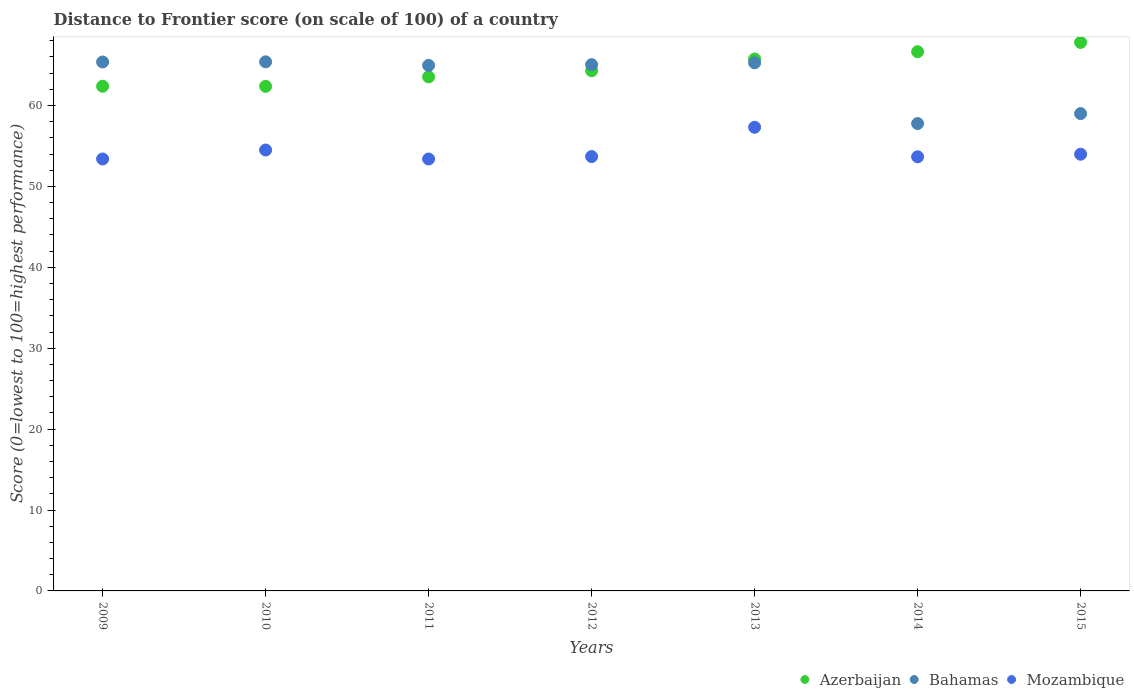Is the number of dotlines equal to the number of legend labels?
Your answer should be compact. Yes. What is the distance to frontier score of in Mozambique in 2010?
Make the answer very short. 54.5. Across all years, what is the maximum distance to frontier score of in Mozambique?
Your answer should be compact. 57.31. Across all years, what is the minimum distance to frontier score of in Azerbaijan?
Keep it short and to the point. 62.37. What is the total distance to frontier score of in Azerbaijan in the graph?
Provide a succinct answer. 452.78. What is the difference between the distance to frontier score of in Bahamas in 2012 and that in 2013?
Offer a very short reply. -0.23. What is the difference between the distance to frontier score of in Azerbaijan in 2014 and the distance to frontier score of in Bahamas in 2009?
Offer a terse response. 1.27. What is the average distance to frontier score of in Azerbaijan per year?
Offer a very short reply. 64.68. In the year 2009, what is the difference between the distance to frontier score of in Bahamas and distance to frontier score of in Azerbaijan?
Offer a terse response. 3. What is the ratio of the distance to frontier score of in Mozambique in 2012 to that in 2014?
Ensure brevity in your answer.  1. What is the difference between the highest and the second highest distance to frontier score of in Mozambique?
Your answer should be compact. 2.81. What is the difference between the highest and the lowest distance to frontier score of in Mozambique?
Ensure brevity in your answer.  3.92. Is the sum of the distance to frontier score of in Bahamas in 2013 and 2014 greater than the maximum distance to frontier score of in Mozambique across all years?
Provide a short and direct response. Yes. Is it the case that in every year, the sum of the distance to frontier score of in Bahamas and distance to frontier score of in Azerbaijan  is greater than the distance to frontier score of in Mozambique?
Ensure brevity in your answer.  Yes. Does the distance to frontier score of in Bahamas monotonically increase over the years?
Ensure brevity in your answer.  No. What is the difference between two consecutive major ticks on the Y-axis?
Provide a short and direct response. 10. Are the values on the major ticks of Y-axis written in scientific E-notation?
Keep it short and to the point. No. Where does the legend appear in the graph?
Make the answer very short. Bottom right. How many legend labels are there?
Provide a short and direct response. 3. What is the title of the graph?
Offer a very short reply. Distance to Frontier score (on scale of 100) of a country. Does "Latin America(developing only)" appear as one of the legend labels in the graph?
Your answer should be very brief. No. What is the label or title of the Y-axis?
Your answer should be very brief. Score (0=lowest to 100=highest performance). What is the Score (0=lowest to 100=highest performance) of Azerbaijan in 2009?
Your answer should be compact. 62.38. What is the Score (0=lowest to 100=highest performance) of Bahamas in 2009?
Offer a terse response. 65.38. What is the Score (0=lowest to 100=highest performance) of Mozambique in 2009?
Offer a very short reply. 53.39. What is the Score (0=lowest to 100=highest performance) of Azerbaijan in 2010?
Provide a succinct answer. 62.37. What is the Score (0=lowest to 100=highest performance) in Bahamas in 2010?
Provide a short and direct response. 65.4. What is the Score (0=lowest to 100=highest performance) of Mozambique in 2010?
Provide a succinct answer. 54.5. What is the Score (0=lowest to 100=highest performance) in Azerbaijan in 2011?
Give a very brief answer. 63.54. What is the Score (0=lowest to 100=highest performance) in Bahamas in 2011?
Give a very brief answer. 64.96. What is the Score (0=lowest to 100=highest performance) in Mozambique in 2011?
Offer a very short reply. 53.39. What is the Score (0=lowest to 100=highest performance) in Azerbaijan in 2012?
Make the answer very short. 64.3. What is the Score (0=lowest to 100=highest performance) in Bahamas in 2012?
Your answer should be compact. 65.05. What is the Score (0=lowest to 100=highest performance) of Mozambique in 2012?
Your answer should be compact. 53.69. What is the Score (0=lowest to 100=highest performance) of Azerbaijan in 2013?
Offer a terse response. 65.74. What is the Score (0=lowest to 100=highest performance) in Bahamas in 2013?
Your answer should be compact. 65.28. What is the Score (0=lowest to 100=highest performance) in Mozambique in 2013?
Offer a terse response. 57.31. What is the Score (0=lowest to 100=highest performance) of Azerbaijan in 2014?
Your response must be concise. 66.65. What is the Score (0=lowest to 100=highest performance) of Bahamas in 2014?
Provide a succinct answer. 57.77. What is the Score (0=lowest to 100=highest performance) of Mozambique in 2014?
Offer a very short reply. 53.66. What is the Score (0=lowest to 100=highest performance) of Azerbaijan in 2015?
Provide a short and direct response. 67.8. What is the Score (0=lowest to 100=highest performance) in Bahamas in 2015?
Keep it short and to the point. 59. What is the Score (0=lowest to 100=highest performance) in Mozambique in 2015?
Provide a succinct answer. 53.98. Across all years, what is the maximum Score (0=lowest to 100=highest performance) of Azerbaijan?
Keep it short and to the point. 67.8. Across all years, what is the maximum Score (0=lowest to 100=highest performance) of Bahamas?
Ensure brevity in your answer.  65.4. Across all years, what is the maximum Score (0=lowest to 100=highest performance) in Mozambique?
Offer a very short reply. 57.31. Across all years, what is the minimum Score (0=lowest to 100=highest performance) in Azerbaijan?
Give a very brief answer. 62.37. Across all years, what is the minimum Score (0=lowest to 100=highest performance) in Bahamas?
Your answer should be very brief. 57.77. Across all years, what is the minimum Score (0=lowest to 100=highest performance) of Mozambique?
Provide a succinct answer. 53.39. What is the total Score (0=lowest to 100=highest performance) of Azerbaijan in the graph?
Provide a succinct answer. 452.78. What is the total Score (0=lowest to 100=highest performance) in Bahamas in the graph?
Offer a very short reply. 442.84. What is the total Score (0=lowest to 100=highest performance) of Mozambique in the graph?
Your response must be concise. 379.92. What is the difference between the Score (0=lowest to 100=highest performance) of Bahamas in 2009 and that in 2010?
Keep it short and to the point. -0.02. What is the difference between the Score (0=lowest to 100=highest performance) in Mozambique in 2009 and that in 2010?
Provide a succinct answer. -1.11. What is the difference between the Score (0=lowest to 100=highest performance) in Azerbaijan in 2009 and that in 2011?
Your answer should be very brief. -1.16. What is the difference between the Score (0=lowest to 100=highest performance) in Bahamas in 2009 and that in 2011?
Provide a short and direct response. 0.42. What is the difference between the Score (0=lowest to 100=highest performance) of Azerbaijan in 2009 and that in 2012?
Offer a terse response. -1.92. What is the difference between the Score (0=lowest to 100=highest performance) of Bahamas in 2009 and that in 2012?
Provide a short and direct response. 0.33. What is the difference between the Score (0=lowest to 100=highest performance) in Mozambique in 2009 and that in 2012?
Provide a succinct answer. -0.3. What is the difference between the Score (0=lowest to 100=highest performance) in Azerbaijan in 2009 and that in 2013?
Your answer should be very brief. -3.36. What is the difference between the Score (0=lowest to 100=highest performance) of Mozambique in 2009 and that in 2013?
Give a very brief answer. -3.92. What is the difference between the Score (0=lowest to 100=highest performance) of Azerbaijan in 2009 and that in 2014?
Keep it short and to the point. -4.27. What is the difference between the Score (0=lowest to 100=highest performance) in Bahamas in 2009 and that in 2014?
Your response must be concise. 7.61. What is the difference between the Score (0=lowest to 100=highest performance) in Mozambique in 2009 and that in 2014?
Ensure brevity in your answer.  -0.27. What is the difference between the Score (0=lowest to 100=highest performance) in Azerbaijan in 2009 and that in 2015?
Provide a succinct answer. -5.42. What is the difference between the Score (0=lowest to 100=highest performance) of Bahamas in 2009 and that in 2015?
Keep it short and to the point. 6.38. What is the difference between the Score (0=lowest to 100=highest performance) in Mozambique in 2009 and that in 2015?
Make the answer very short. -0.59. What is the difference between the Score (0=lowest to 100=highest performance) in Azerbaijan in 2010 and that in 2011?
Keep it short and to the point. -1.17. What is the difference between the Score (0=lowest to 100=highest performance) of Bahamas in 2010 and that in 2011?
Give a very brief answer. 0.44. What is the difference between the Score (0=lowest to 100=highest performance) of Mozambique in 2010 and that in 2011?
Make the answer very short. 1.11. What is the difference between the Score (0=lowest to 100=highest performance) of Azerbaijan in 2010 and that in 2012?
Offer a very short reply. -1.93. What is the difference between the Score (0=lowest to 100=highest performance) of Mozambique in 2010 and that in 2012?
Your answer should be compact. 0.81. What is the difference between the Score (0=lowest to 100=highest performance) of Azerbaijan in 2010 and that in 2013?
Keep it short and to the point. -3.37. What is the difference between the Score (0=lowest to 100=highest performance) of Bahamas in 2010 and that in 2013?
Make the answer very short. 0.12. What is the difference between the Score (0=lowest to 100=highest performance) in Mozambique in 2010 and that in 2013?
Offer a terse response. -2.81. What is the difference between the Score (0=lowest to 100=highest performance) in Azerbaijan in 2010 and that in 2014?
Provide a short and direct response. -4.28. What is the difference between the Score (0=lowest to 100=highest performance) of Bahamas in 2010 and that in 2014?
Ensure brevity in your answer.  7.63. What is the difference between the Score (0=lowest to 100=highest performance) in Mozambique in 2010 and that in 2014?
Provide a succinct answer. 0.84. What is the difference between the Score (0=lowest to 100=highest performance) of Azerbaijan in 2010 and that in 2015?
Your answer should be compact. -5.43. What is the difference between the Score (0=lowest to 100=highest performance) of Mozambique in 2010 and that in 2015?
Give a very brief answer. 0.52. What is the difference between the Score (0=lowest to 100=highest performance) in Azerbaijan in 2011 and that in 2012?
Your answer should be very brief. -0.76. What is the difference between the Score (0=lowest to 100=highest performance) in Bahamas in 2011 and that in 2012?
Give a very brief answer. -0.09. What is the difference between the Score (0=lowest to 100=highest performance) in Mozambique in 2011 and that in 2012?
Offer a terse response. -0.3. What is the difference between the Score (0=lowest to 100=highest performance) of Bahamas in 2011 and that in 2013?
Ensure brevity in your answer.  -0.32. What is the difference between the Score (0=lowest to 100=highest performance) in Mozambique in 2011 and that in 2013?
Offer a terse response. -3.92. What is the difference between the Score (0=lowest to 100=highest performance) of Azerbaijan in 2011 and that in 2014?
Offer a very short reply. -3.11. What is the difference between the Score (0=lowest to 100=highest performance) in Bahamas in 2011 and that in 2014?
Provide a short and direct response. 7.19. What is the difference between the Score (0=lowest to 100=highest performance) in Mozambique in 2011 and that in 2014?
Make the answer very short. -0.27. What is the difference between the Score (0=lowest to 100=highest performance) in Azerbaijan in 2011 and that in 2015?
Your response must be concise. -4.26. What is the difference between the Score (0=lowest to 100=highest performance) of Bahamas in 2011 and that in 2015?
Provide a succinct answer. 5.96. What is the difference between the Score (0=lowest to 100=highest performance) in Mozambique in 2011 and that in 2015?
Ensure brevity in your answer.  -0.59. What is the difference between the Score (0=lowest to 100=highest performance) in Azerbaijan in 2012 and that in 2013?
Keep it short and to the point. -1.44. What is the difference between the Score (0=lowest to 100=highest performance) of Bahamas in 2012 and that in 2013?
Keep it short and to the point. -0.23. What is the difference between the Score (0=lowest to 100=highest performance) of Mozambique in 2012 and that in 2013?
Offer a very short reply. -3.62. What is the difference between the Score (0=lowest to 100=highest performance) of Azerbaijan in 2012 and that in 2014?
Offer a very short reply. -2.35. What is the difference between the Score (0=lowest to 100=highest performance) in Bahamas in 2012 and that in 2014?
Keep it short and to the point. 7.28. What is the difference between the Score (0=lowest to 100=highest performance) of Mozambique in 2012 and that in 2014?
Provide a succinct answer. 0.03. What is the difference between the Score (0=lowest to 100=highest performance) of Bahamas in 2012 and that in 2015?
Ensure brevity in your answer.  6.05. What is the difference between the Score (0=lowest to 100=highest performance) of Mozambique in 2012 and that in 2015?
Provide a succinct answer. -0.29. What is the difference between the Score (0=lowest to 100=highest performance) in Azerbaijan in 2013 and that in 2014?
Your answer should be very brief. -0.91. What is the difference between the Score (0=lowest to 100=highest performance) in Bahamas in 2013 and that in 2014?
Offer a terse response. 7.51. What is the difference between the Score (0=lowest to 100=highest performance) of Mozambique in 2013 and that in 2014?
Your response must be concise. 3.65. What is the difference between the Score (0=lowest to 100=highest performance) of Azerbaijan in 2013 and that in 2015?
Make the answer very short. -2.06. What is the difference between the Score (0=lowest to 100=highest performance) in Bahamas in 2013 and that in 2015?
Your answer should be compact. 6.28. What is the difference between the Score (0=lowest to 100=highest performance) of Mozambique in 2013 and that in 2015?
Offer a terse response. 3.33. What is the difference between the Score (0=lowest to 100=highest performance) in Azerbaijan in 2014 and that in 2015?
Your answer should be compact. -1.15. What is the difference between the Score (0=lowest to 100=highest performance) of Bahamas in 2014 and that in 2015?
Your answer should be compact. -1.23. What is the difference between the Score (0=lowest to 100=highest performance) in Mozambique in 2014 and that in 2015?
Keep it short and to the point. -0.32. What is the difference between the Score (0=lowest to 100=highest performance) of Azerbaijan in 2009 and the Score (0=lowest to 100=highest performance) of Bahamas in 2010?
Your answer should be very brief. -3.02. What is the difference between the Score (0=lowest to 100=highest performance) in Azerbaijan in 2009 and the Score (0=lowest to 100=highest performance) in Mozambique in 2010?
Keep it short and to the point. 7.88. What is the difference between the Score (0=lowest to 100=highest performance) in Bahamas in 2009 and the Score (0=lowest to 100=highest performance) in Mozambique in 2010?
Give a very brief answer. 10.88. What is the difference between the Score (0=lowest to 100=highest performance) of Azerbaijan in 2009 and the Score (0=lowest to 100=highest performance) of Bahamas in 2011?
Your answer should be very brief. -2.58. What is the difference between the Score (0=lowest to 100=highest performance) in Azerbaijan in 2009 and the Score (0=lowest to 100=highest performance) in Mozambique in 2011?
Offer a terse response. 8.99. What is the difference between the Score (0=lowest to 100=highest performance) in Bahamas in 2009 and the Score (0=lowest to 100=highest performance) in Mozambique in 2011?
Your answer should be very brief. 11.99. What is the difference between the Score (0=lowest to 100=highest performance) in Azerbaijan in 2009 and the Score (0=lowest to 100=highest performance) in Bahamas in 2012?
Offer a very short reply. -2.67. What is the difference between the Score (0=lowest to 100=highest performance) in Azerbaijan in 2009 and the Score (0=lowest to 100=highest performance) in Mozambique in 2012?
Offer a very short reply. 8.69. What is the difference between the Score (0=lowest to 100=highest performance) of Bahamas in 2009 and the Score (0=lowest to 100=highest performance) of Mozambique in 2012?
Offer a terse response. 11.69. What is the difference between the Score (0=lowest to 100=highest performance) in Azerbaijan in 2009 and the Score (0=lowest to 100=highest performance) in Bahamas in 2013?
Your response must be concise. -2.9. What is the difference between the Score (0=lowest to 100=highest performance) of Azerbaijan in 2009 and the Score (0=lowest to 100=highest performance) of Mozambique in 2013?
Your answer should be compact. 5.07. What is the difference between the Score (0=lowest to 100=highest performance) in Bahamas in 2009 and the Score (0=lowest to 100=highest performance) in Mozambique in 2013?
Your answer should be compact. 8.07. What is the difference between the Score (0=lowest to 100=highest performance) of Azerbaijan in 2009 and the Score (0=lowest to 100=highest performance) of Bahamas in 2014?
Make the answer very short. 4.61. What is the difference between the Score (0=lowest to 100=highest performance) in Azerbaijan in 2009 and the Score (0=lowest to 100=highest performance) in Mozambique in 2014?
Your answer should be very brief. 8.72. What is the difference between the Score (0=lowest to 100=highest performance) in Bahamas in 2009 and the Score (0=lowest to 100=highest performance) in Mozambique in 2014?
Provide a succinct answer. 11.72. What is the difference between the Score (0=lowest to 100=highest performance) of Azerbaijan in 2009 and the Score (0=lowest to 100=highest performance) of Bahamas in 2015?
Give a very brief answer. 3.38. What is the difference between the Score (0=lowest to 100=highest performance) of Azerbaijan in 2009 and the Score (0=lowest to 100=highest performance) of Mozambique in 2015?
Offer a terse response. 8.4. What is the difference between the Score (0=lowest to 100=highest performance) of Bahamas in 2009 and the Score (0=lowest to 100=highest performance) of Mozambique in 2015?
Offer a terse response. 11.4. What is the difference between the Score (0=lowest to 100=highest performance) of Azerbaijan in 2010 and the Score (0=lowest to 100=highest performance) of Bahamas in 2011?
Provide a succinct answer. -2.59. What is the difference between the Score (0=lowest to 100=highest performance) of Azerbaijan in 2010 and the Score (0=lowest to 100=highest performance) of Mozambique in 2011?
Your response must be concise. 8.98. What is the difference between the Score (0=lowest to 100=highest performance) of Bahamas in 2010 and the Score (0=lowest to 100=highest performance) of Mozambique in 2011?
Your answer should be very brief. 12.01. What is the difference between the Score (0=lowest to 100=highest performance) of Azerbaijan in 2010 and the Score (0=lowest to 100=highest performance) of Bahamas in 2012?
Offer a terse response. -2.68. What is the difference between the Score (0=lowest to 100=highest performance) of Azerbaijan in 2010 and the Score (0=lowest to 100=highest performance) of Mozambique in 2012?
Offer a very short reply. 8.68. What is the difference between the Score (0=lowest to 100=highest performance) in Bahamas in 2010 and the Score (0=lowest to 100=highest performance) in Mozambique in 2012?
Provide a short and direct response. 11.71. What is the difference between the Score (0=lowest to 100=highest performance) in Azerbaijan in 2010 and the Score (0=lowest to 100=highest performance) in Bahamas in 2013?
Make the answer very short. -2.91. What is the difference between the Score (0=lowest to 100=highest performance) in Azerbaijan in 2010 and the Score (0=lowest to 100=highest performance) in Mozambique in 2013?
Offer a very short reply. 5.06. What is the difference between the Score (0=lowest to 100=highest performance) in Bahamas in 2010 and the Score (0=lowest to 100=highest performance) in Mozambique in 2013?
Offer a very short reply. 8.09. What is the difference between the Score (0=lowest to 100=highest performance) of Azerbaijan in 2010 and the Score (0=lowest to 100=highest performance) of Bahamas in 2014?
Ensure brevity in your answer.  4.6. What is the difference between the Score (0=lowest to 100=highest performance) in Azerbaijan in 2010 and the Score (0=lowest to 100=highest performance) in Mozambique in 2014?
Offer a terse response. 8.71. What is the difference between the Score (0=lowest to 100=highest performance) in Bahamas in 2010 and the Score (0=lowest to 100=highest performance) in Mozambique in 2014?
Your answer should be compact. 11.74. What is the difference between the Score (0=lowest to 100=highest performance) in Azerbaijan in 2010 and the Score (0=lowest to 100=highest performance) in Bahamas in 2015?
Offer a very short reply. 3.37. What is the difference between the Score (0=lowest to 100=highest performance) of Azerbaijan in 2010 and the Score (0=lowest to 100=highest performance) of Mozambique in 2015?
Offer a very short reply. 8.39. What is the difference between the Score (0=lowest to 100=highest performance) of Bahamas in 2010 and the Score (0=lowest to 100=highest performance) of Mozambique in 2015?
Ensure brevity in your answer.  11.42. What is the difference between the Score (0=lowest to 100=highest performance) of Azerbaijan in 2011 and the Score (0=lowest to 100=highest performance) of Bahamas in 2012?
Your answer should be very brief. -1.51. What is the difference between the Score (0=lowest to 100=highest performance) of Azerbaijan in 2011 and the Score (0=lowest to 100=highest performance) of Mozambique in 2012?
Your response must be concise. 9.85. What is the difference between the Score (0=lowest to 100=highest performance) of Bahamas in 2011 and the Score (0=lowest to 100=highest performance) of Mozambique in 2012?
Offer a terse response. 11.27. What is the difference between the Score (0=lowest to 100=highest performance) of Azerbaijan in 2011 and the Score (0=lowest to 100=highest performance) of Bahamas in 2013?
Your response must be concise. -1.74. What is the difference between the Score (0=lowest to 100=highest performance) of Azerbaijan in 2011 and the Score (0=lowest to 100=highest performance) of Mozambique in 2013?
Keep it short and to the point. 6.23. What is the difference between the Score (0=lowest to 100=highest performance) in Bahamas in 2011 and the Score (0=lowest to 100=highest performance) in Mozambique in 2013?
Offer a very short reply. 7.65. What is the difference between the Score (0=lowest to 100=highest performance) of Azerbaijan in 2011 and the Score (0=lowest to 100=highest performance) of Bahamas in 2014?
Make the answer very short. 5.77. What is the difference between the Score (0=lowest to 100=highest performance) in Azerbaijan in 2011 and the Score (0=lowest to 100=highest performance) in Mozambique in 2014?
Give a very brief answer. 9.88. What is the difference between the Score (0=lowest to 100=highest performance) in Bahamas in 2011 and the Score (0=lowest to 100=highest performance) in Mozambique in 2014?
Your response must be concise. 11.3. What is the difference between the Score (0=lowest to 100=highest performance) of Azerbaijan in 2011 and the Score (0=lowest to 100=highest performance) of Bahamas in 2015?
Provide a short and direct response. 4.54. What is the difference between the Score (0=lowest to 100=highest performance) in Azerbaijan in 2011 and the Score (0=lowest to 100=highest performance) in Mozambique in 2015?
Provide a succinct answer. 9.56. What is the difference between the Score (0=lowest to 100=highest performance) of Bahamas in 2011 and the Score (0=lowest to 100=highest performance) of Mozambique in 2015?
Provide a succinct answer. 10.98. What is the difference between the Score (0=lowest to 100=highest performance) in Azerbaijan in 2012 and the Score (0=lowest to 100=highest performance) in Bahamas in 2013?
Your answer should be very brief. -0.98. What is the difference between the Score (0=lowest to 100=highest performance) of Azerbaijan in 2012 and the Score (0=lowest to 100=highest performance) of Mozambique in 2013?
Ensure brevity in your answer.  6.99. What is the difference between the Score (0=lowest to 100=highest performance) in Bahamas in 2012 and the Score (0=lowest to 100=highest performance) in Mozambique in 2013?
Make the answer very short. 7.74. What is the difference between the Score (0=lowest to 100=highest performance) of Azerbaijan in 2012 and the Score (0=lowest to 100=highest performance) of Bahamas in 2014?
Ensure brevity in your answer.  6.53. What is the difference between the Score (0=lowest to 100=highest performance) in Azerbaijan in 2012 and the Score (0=lowest to 100=highest performance) in Mozambique in 2014?
Provide a succinct answer. 10.64. What is the difference between the Score (0=lowest to 100=highest performance) in Bahamas in 2012 and the Score (0=lowest to 100=highest performance) in Mozambique in 2014?
Give a very brief answer. 11.39. What is the difference between the Score (0=lowest to 100=highest performance) of Azerbaijan in 2012 and the Score (0=lowest to 100=highest performance) of Mozambique in 2015?
Give a very brief answer. 10.32. What is the difference between the Score (0=lowest to 100=highest performance) of Bahamas in 2012 and the Score (0=lowest to 100=highest performance) of Mozambique in 2015?
Offer a terse response. 11.07. What is the difference between the Score (0=lowest to 100=highest performance) of Azerbaijan in 2013 and the Score (0=lowest to 100=highest performance) of Bahamas in 2014?
Provide a succinct answer. 7.97. What is the difference between the Score (0=lowest to 100=highest performance) of Azerbaijan in 2013 and the Score (0=lowest to 100=highest performance) of Mozambique in 2014?
Keep it short and to the point. 12.08. What is the difference between the Score (0=lowest to 100=highest performance) in Bahamas in 2013 and the Score (0=lowest to 100=highest performance) in Mozambique in 2014?
Your answer should be very brief. 11.62. What is the difference between the Score (0=lowest to 100=highest performance) of Azerbaijan in 2013 and the Score (0=lowest to 100=highest performance) of Bahamas in 2015?
Your response must be concise. 6.74. What is the difference between the Score (0=lowest to 100=highest performance) of Azerbaijan in 2013 and the Score (0=lowest to 100=highest performance) of Mozambique in 2015?
Provide a short and direct response. 11.76. What is the difference between the Score (0=lowest to 100=highest performance) of Azerbaijan in 2014 and the Score (0=lowest to 100=highest performance) of Bahamas in 2015?
Ensure brevity in your answer.  7.65. What is the difference between the Score (0=lowest to 100=highest performance) in Azerbaijan in 2014 and the Score (0=lowest to 100=highest performance) in Mozambique in 2015?
Offer a terse response. 12.67. What is the difference between the Score (0=lowest to 100=highest performance) in Bahamas in 2014 and the Score (0=lowest to 100=highest performance) in Mozambique in 2015?
Give a very brief answer. 3.79. What is the average Score (0=lowest to 100=highest performance) in Azerbaijan per year?
Ensure brevity in your answer.  64.68. What is the average Score (0=lowest to 100=highest performance) in Bahamas per year?
Provide a succinct answer. 63.26. What is the average Score (0=lowest to 100=highest performance) of Mozambique per year?
Your answer should be very brief. 54.27. In the year 2009, what is the difference between the Score (0=lowest to 100=highest performance) of Azerbaijan and Score (0=lowest to 100=highest performance) of Bahamas?
Provide a succinct answer. -3. In the year 2009, what is the difference between the Score (0=lowest to 100=highest performance) in Azerbaijan and Score (0=lowest to 100=highest performance) in Mozambique?
Ensure brevity in your answer.  8.99. In the year 2009, what is the difference between the Score (0=lowest to 100=highest performance) of Bahamas and Score (0=lowest to 100=highest performance) of Mozambique?
Your answer should be very brief. 11.99. In the year 2010, what is the difference between the Score (0=lowest to 100=highest performance) in Azerbaijan and Score (0=lowest to 100=highest performance) in Bahamas?
Your answer should be very brief. -3.03. In the year 2010, what is the difference between the Score (0=lowest to 100=highest performance) of Azerbaijan and Score (0=lowest to 100=highest performance) of Mozambique?
Make the answer very short. 7.87. In the year 2010, what is the difference between the Score (0=lowest to 100=highest performance) in Bahamas and Score (0=lowest to 100=highest performance) in Mozambique?
Offer a terse response. 10.9. In the year 2011, what is the difference between the Score (0=lowest to 100=highest performance) in Azerbaijan and Score (0=lowest to 100=highest performance) in Bahamas?
Your answer should be compact. -1.42. In the year 2011, what is the difference between the Score (0=lowest to 100=highest performance) of Azerbaijan and Score (0=lowest to 100=highest performance) of Mozambique?
Keep it short and to the point. 10.15. In the year 2011, what is the difference between the Score (0=lowest to 100=highest performance) in Bahamas and Score (0=lowest to 100=highest performance) in Mozambique?
Give a very brief answer. 11.57. In the year 2012, what is the difference between the Score (0=lowest to 100=highest performance) of Azerbaijan and Score (0=lowest to 100=highest performance) of Bahamas?
Keep it short and to the point. -0.75. In the year 2012, what is the difference between the Score (0=lowest to 100=highest performance) in Azerbaijan and Score (0=lowest to 100=highest performance) in Mozambique?
Provide a short and direct response. 10.61. In the year 2012, what is the difference between the Score (0=lowest to 100=highest performance) of Bahamas and Score (0=lowest to 100=highest performance) of Mozambique?
Provide a succinct answer. 11.36. In the year 2013, what is the difference between the Score (0=lowest to 100=highest performance) in Azerbaijan and Score (0=lowest to 100=highest performance) in Bahamas?
Your response must be concise. 0.46. In the year 2013, what is the difference between the Score (0=lowest to 100=highest performance) of Azerbaijan and Score (0=lowest to 100=highest performance) of Mozambique?
Provide a succinct answer. 8.43. In the year 2013, what is the difference between the Score (0=lowest to 100=highest performance) in Bahamas and Score (0=lowest to 100=highest performance) in Mozambique?
Give a very brief answer. 7.97. In the year 2014, what is the difference between the Score (0=lowest to 100=highest performance) of Azerbaijan and Score (0=lowest to 100=highest performance) of Bahamas?
Your answer should be compact. 8.88. In the year 2014, what is the difference between the Score (0=lowest to 100=highest performance) in Azerbaijan and Score (0=lowest to 100=highest performance) in Mozambique?
Your answer should be compact. 12.99. In the year 2014, what is the difference between the Score (0=lowest to 100=highest performance) of Bahamas and Score (0=lowest to 100=highest performance) of Mozambique?
Ensure brevity in your answer.  4.11. In the year 2015, what is the difference between the Score (0=lowest to 100=highest performance) of Azerbaijan and Score (0=lowest to 100=highest performance) of Mozambique?
Provide a succinct answer. 13.82. In the year 2015, what is the difference between the Score (0=lowest to 100=highest performance) in Bahamas and Score (0=lowest to 100=highest performance) in Mozambique?
Keep it short and to the point. 5.02. What is the ratio of the Score (0=lowest to 100=highest performance) of Bahamas in 2009 to that in 2010?
Ensure brevity in your answer.  1. What is the ratio of the Score (0=lowest to 100=highest performance) in Mozambique in 2009 to that in 2010?
Provide a succinct answer. 0.98. What is the ratio of the Score (0=lowest to 100=highest performance) of Azerbaijan in 2009 to that in 2011?
Make the answer very short. 0.98. What is the ratio of the Score (0=lowest to 100=highest performance) of Azerbaijan in 2009 to that in 2012?
Your answer should be very brief. 0.97. What is the ratio of the Score (0=lowest to 100=highest performance) in Bahamas in 2009 to that in 2012?
Your answer should be compact. 1.01. What is the ratio of the Score (0=lowest to 100=highest performance) in Mozambique in 2009 to that in 2012?
Your answer should be compact. 0.99. What is the ratio of the Score (0=lowest to 100=highest performance) in Azerbaijan in 2009 to that in 2013?
Your answer should be very brief. 0.95. What is the ratio of the Score (0=lowest to 100=highest performance) in Bahamas in 2009 to that in 2013?
Keep it short and to the point. 1. What is the ratio of the Score (0=lowest to 100=highest performance) in Mozambique in 2009 to that in 2013?
Ensure brevity in your answer.  0.93. What is the ratio of the Score (0=lowest to 100=highest performance) in Azerbaijan in 2009 to that in 2014?
Ensure brevity in your answer.  0.94. What is the ratio of the Score (0=lowest to 100=highest performance) of Bahamas in 2009 to that in 2014?
Your response must be concise. 1.13. What is the ratio of the Score (0=lowest to 100=highest performance) in Mozambique in 2009 to that in 2014?
Offer a terse response. 0.99. What is the ratio of the Score (0=lowest to 100=highest performance) in Azerbaijan in 2009 to that in 2015?
Ensure brevity in your answer.  0.92. What is the ratio of the Score (0=lowest to 100=highest performance) in Bahamas in 2009 to that in 2015?
Make the answer very short. 1.11. What is the ratio of the Score (0=lowest to 100=highest performance) of Azerbaijan in 2010 to that in 2011?
Offer a terse response. 0.98. What is the ratio of the Score (0=lowest to 100=highest performance) of Bahamas in 2010 to that in 2011?
Provide a short and direct response. 1.01. What is the ratio of the Score (0=lowest to 100=highest performance) in Mozambique in 2010 to that in 2011?
Your answer should be compact. 1.02. What is the ratio of the Score (0=lowest to 100=highest performance) in Azerbaijan in 2010 to that in 2012?
Your answer should be very brief. 0.97. What is the ratio of the Score (0=lowest to 100=highest performance) in Bahamas in 2010 to that in 2012?
Keep it short and to the point. 1.01. What is the ratio of the Score (0=lowest to 100=highest performance) of Mozambique in 2010 to that in 2012?
Your answer should be compact. 1.02. What is the ratio of the Score (0=lowest to 100=highest performance) of Azerbaijan in 2010 to that in 2013?
Make the answer very short. 0.95. What is the ratio of the Score (0=lowest to 100=highest performance) in Bahamas in 2010 to that in 2013?
Your answer should be very brief. 1. What is the ratio of the Score (0=lowest to 100=highest performance) of Mozambique in 2010 to that in 2013?
Provide a short and direct response. 0.95. What is the ratio of the Score (0=lowest to 100=highest performance) in Azerbaijan in 2010 to that in 2014?
Your answer should be very brief. 0.94. What is the ratio of the Score (0=lowest to 100=highest performance) of Bahamas in 2010 to that in 2014?
Your answer should be very brief. 1.13. What is the ratio of the Score (0=lowest to 100=highest performance) in Mozambique in 2010 to that in 2014?
Offer a very short reply. 1.02. What is the ratio of the Score (0=lowest to 100=highest performance) in Azerbaijan in 2010 to that in 2015?
Provide a succinct answer. 0.92. What is the ratio of the Score (0=lowest to 100=highest performance) of Bahamas in 2010 to that in 2015?
Offer a very short reply. 1.11. What is the ratio of the Score (0=lowest to 100=highest performance) in Mozambique in 2010 to that in 2015?
Your answer should be compact. 1.01. What is the ratio of the Score (0=lowest to 100=highest performance) of Azerbaijan in 2011 to that in 2012?
Give a very brief answer. 0.99. What is the ratio of the Score (0=lowest to 100=highest performance) in Bahamas in 2011 to that in 2012?
Give a very brief answer. 1. What is the ratio of the Score (0=lowest to 100=highest performance) in Azerbaijan in 2011 to that in 2013?
Your answer should be compact. 0.97. What is the ratio of the Score (0=lowest to 100=highest performance) in Bahamas in 2011 to that in 2013?
Keep it short and to the point. 1. What is the ratio of the Score (0=lowest to 100=highest performance) in Mozambique in 2011 to that in 2013?
Offer a terse response. 0.93. What is the ratio of the Score (0=lowest to 100=highest performance) in Azerbaijan in 2011 to that in 2014?
Offer a terse response. 0.95. What is the ratio of the Score (0=lowest to 100=highest performance) in Bahamas in 2011 to that in 2014?
Your answer should be very brief. 1.12. What is the ratio of the Score (0=lowest to 100=highest performance) in Mozambique in 2011 to that in 2014?
Ensure brevity in your answer.  0.99. What is the ratio of the Score (0=lowest to 100=highest performance) in Azerbaijan in 2011 to that in 2015?
Offer a very short reply. 0.94. What is the ratio of the Score (0=lowest to 100=highest performance) of Bahamas in 2011 to that in 2015?
Provide a short and direct response. 1.1. What is the ratio of the Score (0=lowest to 100=highest performance) of Azerbaijan in 2012 to that in 2013?
Your answer should be very brief. 0.98. What is the ratio of the Score (0=lowest to 100=highest performance) in Bahamas in 2012 to that in 2013?
Ensure brevity in your answer.  1. What is the ratio of the Score (0=lowest to 100=highest performance) in Mozambique in 2012 to that in 2013?
Provide a short and direct response. 0.94. What is the ratio of the Score (0=lowest to 100=highest performance) in Azerbaijan in 2012 to that in 2014?
Make the answer very short. 0.96. What is the ratio of the Score (0=lowest to 100=highest performance) of Bahamas in 2012 to that in 2014?
Give a very brief answer. 1.13. What is the ratio of the Score (0=lowest to 100=highest performance) in Mozambique in 2012 to that in 2014?
Ensure brevity in your answer.  1. What is the ratio of the Score (0=lowest to 100=highest performance) of Azerbaijan in 2012 to that in 2015?
Your answer should be very brief. 0.95. What is the ratio of the Score (0=lowest to 100=highest performance) in Bahamas in 2012 to that in 2015?
Your answer should be very brief. 1.1. What is the ratio of the Score (0=lowest to 100=highest performance) in Mozambique in 2012 to that in 2015?
Provide a succinct answer. 0.99. What is the ratio of the Score (0=lowest to 100=highest performance) in Azerbaijan in 2013 to that in 2014?
Make the answer very short. 0.99. What is the ratio of the Score (0=lowest to 100=highest performance) in Bahamas in 2013 to that in 2014?
Give a very brief answer. 1.13. What is the ratio of the Score (0=lowest to 100=highest performance) in Mozambique in 2013 to that in 2014?
Provide a succinct answer. 1.07. What is the ratio of the Score (0=lowest to 100=highest performance) of Azerbaijan in 2013 to that in 2015?
Your response must be concise. 0.97. What is the ratio of the Score (0=lowest to 100=highest performance) of Bahamas in 2013 to that in 2015?
Provide a succinct answer. 1.11. What is the ratio of the Score (0=lowest to 100=highest performance) in Mozambique in 2013 to that in 2015?
Your response must be concise. 1.06. What is the ratio of the Score (0=lowest to 100=highest performance) in Bahamas in 2014 to that in 2015?
Provide a succinct answer. 0.98. What is the difference between the highest and the second highest Score (0=lowest to 100=highest performance) of Azerbaijan?
Provide a short and direct response. 1.15. What is the difference between the highest and the second highest Score (0=lowest to 100=highest performance) of Bahamas?
Make the answer very short. 0.02. What is the difference between the highest and the second highest Score (0=lowest to 100=highest performance) in Mozambique?
Offer a very short reply. 2.81. What is the difference between the highest and the lowest Score (0=lowest to 100=highest performance) in Azerbaijan?
Your response must be concise. 5.43. What is the difference between the highest and the lowest Score (0=lowest to 100=highest performance) in Bahamas?
Your answer should be very brief. 7.63. What is the difference between the highest and the lowest Score (0=lowest to 100=highest performance) of Mozambique?
Make the answer very short. 3.92. 